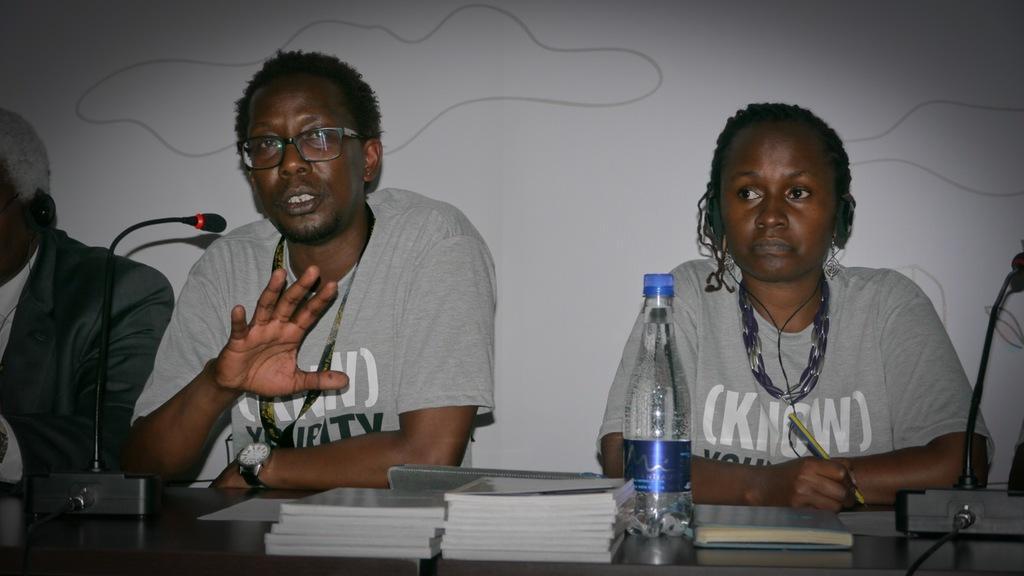Could you give a brief overview of what you see in this image? On the right a man is speaking in the microphone and. He wears a T-Shirt and there is a water bottle on the table and a woman is sitting. 